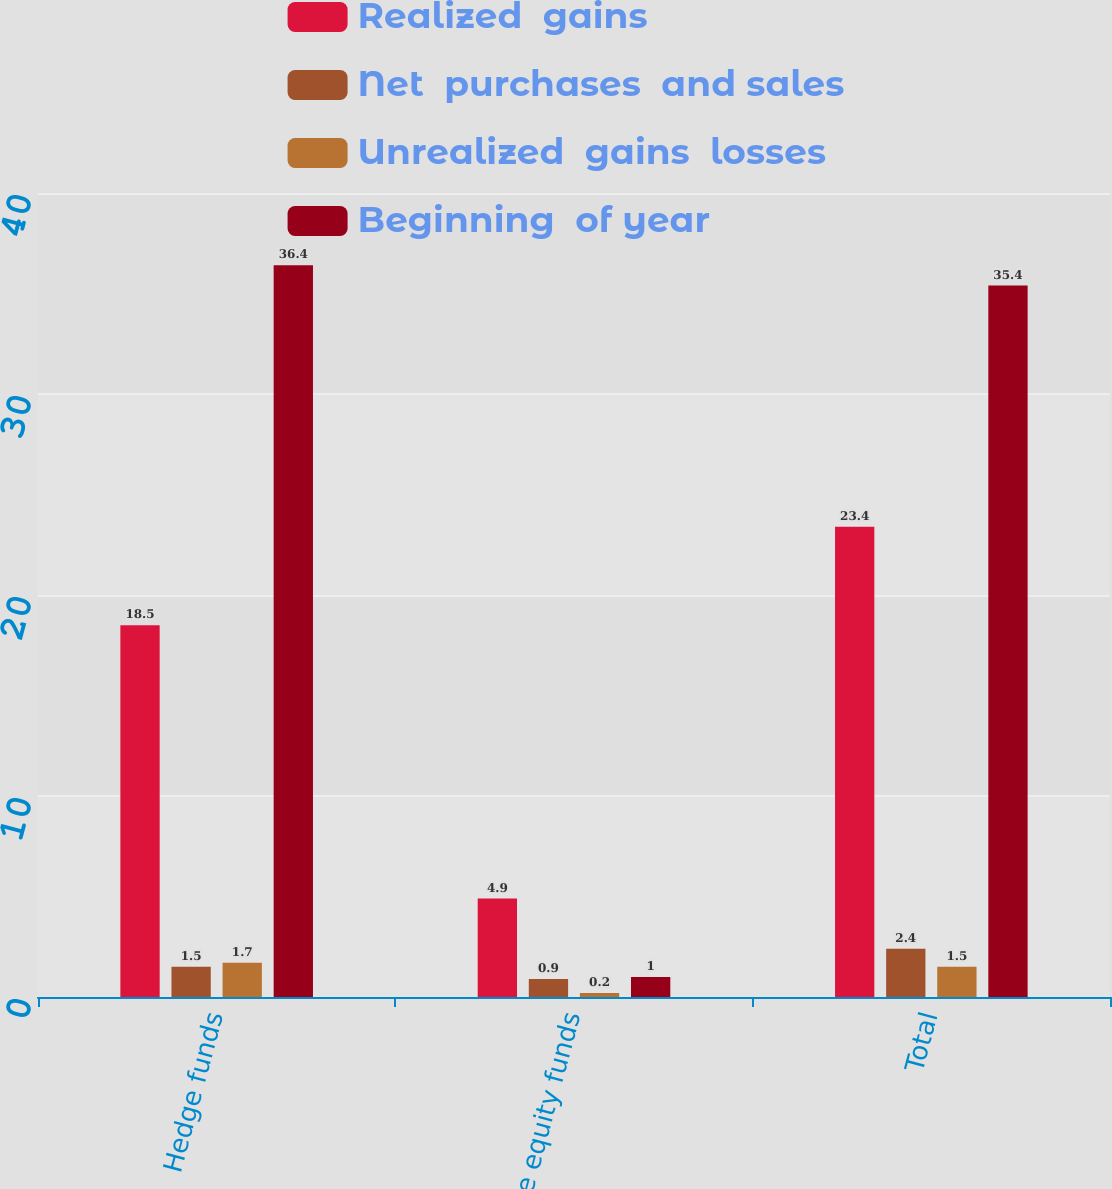Convert chart to OTSL. <chart><loc_0><loc_0><loc_500><loc_500><stacked_bar_chart><ecel><fcel>Hedge funds<fcel>Private equity funds<fcel>Total<nl><fcel>Realized  gains<fcel>18.5<fcel>4.9<fcel>23.4<nl><fcel>Net  purchases  and sales<fcel>1.5<fcel>0.9<fcel>2.4<nl><fcel>Unrealized  gains  losses<fcel>1.7<fcel>0.2<fcel>1.5<nl><fcel>Beginning  of year<fcel>36.4<fcel>1<fcel>35.4<nl></chart> 